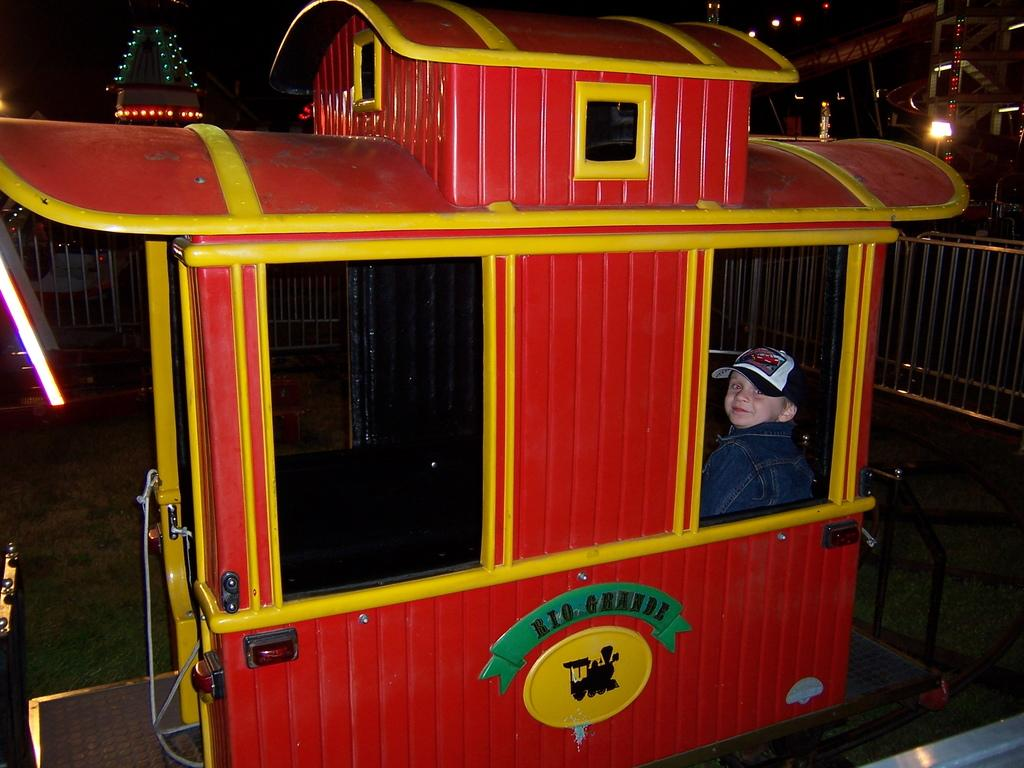Who is the main subject in the image? There is a boy in the image. What is the boy doing in the image? The boy is sitting in a toy train. What can be seen in the background of the image? There is a railing in the background of the image. What else is visible in the image besides the boy and the toy train? There are lights visible in the image. What type of degree does the fish in the image have? There is no fish present in the image, so it is not possible to determine what type of degree it might have. 